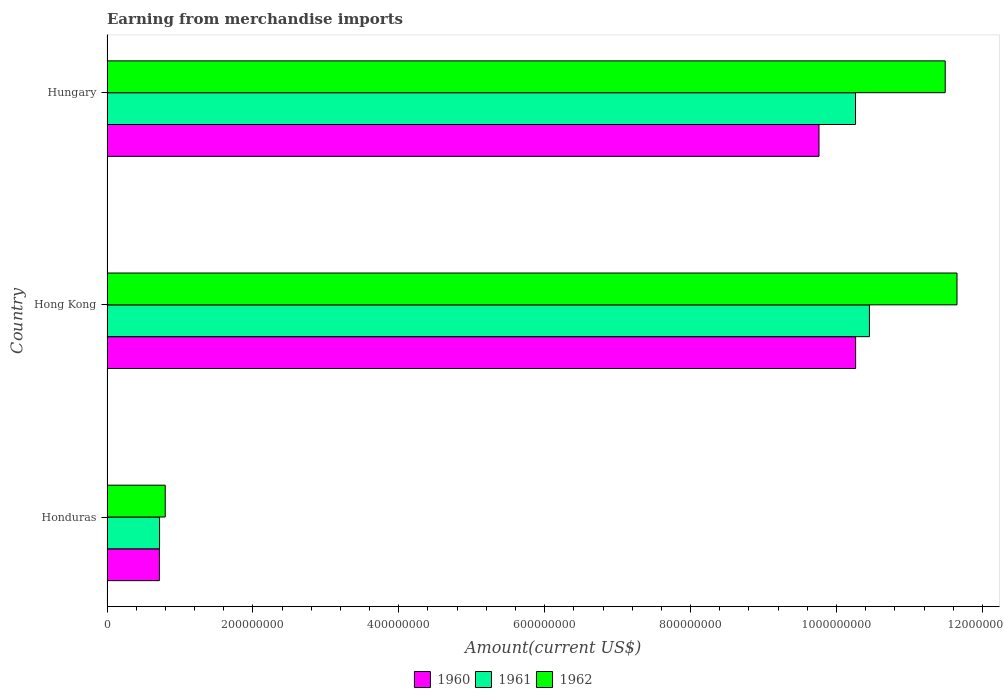How many different coloured bars are there?
Offer a very short reply. 3. Are the number of bars per tick equal to the number of legend labels?
Offer a terse response. Yes. How many bars are there on the 2nd tick from the top?
Your response must be concise. 3. What is the label of the 2nd group of bars from the top?
Give a very brief answer. Hong Kong. In how many cases, is the number of bars for a given country not equal to the number of legend labels?
Offer a terse response. 0. What is the amount earned from merchandise imports in 1961 in Honduras?
Make the answer very short. 7.20e+07. Across all countries, what is the maximum amount earned from merchandise imports in 1962?
Give a very brief answer. 1.17e+09. Across all countries, what is the minimum amount earned from merchandise imports in 1961?
Offer a terse response. 7.20e+07. In which country was the amount earned from merchandise imports in 1961 maximum?
Your response must be concise. Hong Kong. In which country was the amount earned from merchandise imports in 1960 minimum?
Keep it short and to the point. Honduras. What is the total amount earned from merchandise imports in 1962 in the graph?
Make the answer very short. 2.39e+09. What is the difference between the amount earned from merchandise imports in 1962 in Honduras and that in Hungary?
Provide a short and direct response. -1.07e+09. What is the average amount earned from merchandise imports in 1961 per country?
Offer a terse response. 7.14e+08. What is the difference between the amount earned from merchandise imports in 1961 and amount earned from merchandise imports in 1962 in Hungary?
Your response must be concise. -1.23e+08. What is the ratio of the amount earned from merchandise imports in 1960 in Hong Kong to that in Hungary?
Ensure brevity in your answer.  1.05. Is the amount earned from merchandise imports in 1962 in Honduras less than that in Hong Kong?
Offer a very short reply. Yes. What is the difference between the highest and the second highest amount earned from merchandise imports in 1962?
Your answer should be compact. 1.62e+07. What is the difference between the highest and the lowest amount earned from merchandise imports in 1962?
Ensure brevity in your answer.  1.09e+09. In how many countries, is the amount earned from merchandise imports in 1960 greater than the average amount earned from merchandise imports in 1960 taken over all countries?
Make the answer very short. 2. What does the 1st bar from the top in Hungary represents?
Your answer should be very brief. 1962. What does the 1st bar from the bottom in Hong Kong represents?
Offer a very short reply. 1960. Is it the case that in every country, the sum of the amount earned from merchandise imports in 1961 and amount earned from merchandise imports in 1962 is greater than the amount earned from merchandise imports in 1960?
Provide a succinct answer. Yes. How many countries are there in the graph?
Offer a terse response. 3. Where does the legend appear in the graph?
Give a very brief answer. Bottom center. What is the title of the graph?
Keep it short and to the point. Earning from merchandise imports. What is the label or title of the X-axis?
Your answer should be very brief. Amount(current US$). What is the Amount(current US$) of 1960 in Honduras?
Ensure brevity in your answer.  7.18e+07. What is the Amount(current US$) of 1961 in Honduras?
Give a very brief answer. 7.20e+07. What is the Amount(current US$) of 1962 in Honduras?
Ensure brevity in your answer.  7.98e+07. What is the Amount(current US$) in 1960 in Hong Kong?
Give a very brief answer. 1.03e+09. What is the Amount(current US$) of 1961 in Hong Kong?
Provide a short and direct response. 1.05e+09. What is the Amount(current US$) in 1962 in Hong Kong?
Ensure brevity in your answer.  1.17e+09. What is the Amount(current US$) of 1960 in Hungary?
Ensure brevity in your answer.  9.76e+08. What is the Amount(current US$) in 1961 in Hungary?
Provide a short and direct response. 1.03e+09. What is the Amount(current US$) of 1962 in Hungary?
Provide a succinct answer. 1.15e+09. Across all countries, what is the maximum Amount(current US$) in 1960?
Make the answer very short. 1.03e+09. Across all countries, what is the maximum Amount(current US$) in 1961?
Keep it short and to the point. 1.05e+09. Across all countries, what is the maximum Amount(current US$) in 1962?
Provide a succinct answer. 1.17e+09. Across all countries, what is the minimum Amount(current US$) in 1960?
Provide a short and direct response. 7.18e+07. Across all countries, what is the minimum Amount(current US$) of 1961?
Your response must be concise. 7.20e+07. Across all countries, what is the minimum Amount(current US$) of 1962?
Your answer should be compact. 7.98e+07. What is the total Amount(current US$) in 1960 in the graph?
Ensure brevity in your answer.  2.07e+09. What is the total Amount(current US$) in 1961 in the graph?
Provide a short and direct response. 2.14e+09. What is the total Amount(current US$) of 1962 in the graph?
Your response must be concise. 2.39e+09. What is the difference between the Amount(current US$) in 1960 in Honduras and that in Hong Kong?
Your answer should be very brief. -9.54e+08. What is the difference between the Amount(current US$) of 1961 in Honduras and that in Hong Kong?
Ensure brevity in your answer.  -9.73e+08. What is the difference between the Amount(current US$) of 1962 in Honduras and that in Hong Kong?
Ensure brevity in your answer.  -1.09e+09. What is the difference between the Amount(current US$) in 1960 in Honduras and that in Hungary?
Your answer should be compact. -9.04e+08. What is the difference between the Amount(current US$) in 1961 in Honduras and that in Hungary?
Offer a terse response. -9.54e+08. What is the difference between the Amount(current US$) of 1962 in Honduras and that in Hungary?
Provide a succinct answer. -1.07e+09. What is the difference between the Amount(current US$) of 1960 in Hong Kong and that in Hungary?
Your response must be concise. 5.02e+07. What is the difference between the Amount(current US$) of 1961 in Hong Kong and that in Hungary?
Offer a terse response. 1.91e+07. What is the difference between the Amount(current US$) of 1962 in Hong Kong and that in Hungary?
Provide a succinct answer. 1.62e+07. What is the difference between the Amount(current US$) of 1960 in Honduras and the Amount(current US$) of 1961 in Hong Kong?
Provide a succinct answer. -9.73e+08. What is the difference between the Amount(current US$) of 1960 in Honduras and the Amount(current US$) of 1962 in Hong Kong?
Offer a very short reply. -1.09e+09. What is the difference between the Amount(current US$) in 1961 in Honduras and the Amount(current US$) in 1962 in Hong Kong?
Provide a succinct answer. -1.09e+09. What is the difference between the Amount(current US$) of 1960 in Honduras and the Amount(current US$) of 1961 in Hungary?
Offer a very short reply. -9.54e+08. What is the difference between the Amount(current US$) in 1960 in Honduras and the Amount(current US$) in 1962 in Hungary?
Give a very brief answer. -1.08e+09. What is the difference between the Amount(current US$) in 1961 in Honduras and the Amount(current US$) in 1962 in Hungary?
Provide a succinct answer. -1.08e+09. What is the difference between the Amount(current US$) of 1960 in Hong Kong and the Amount(current US$) of 1961 in Hungary?
Your response must be concise. 2.00e+05. What is the difference between the Amount(current US$) of 1960 in Hong Kong and the Amount(current US$) of 1962 in Hungary?
Give a very brief answer. -1.23e+08. What is the difference between the Amount(current US$) of 1961 in Hong Kong and the Amount(current US$) of 1962 in Hungary?
Keep it short and to the point. -1.04e+08. What is the average Amount(current US$) in 1960 per country?
Offer a very short reply. 6.91e+08. What is the average Amount(current US$) in 1961 per country?
Your answer should be very brief. 7.14e+08. What is the average Amount(current US$) in 1962 per country?
Your answer should be very brief. 7.98e+08. What is the difference between the Amount(current US$) in 1960 and Amount(current US$) in 1962 in Honduras?
Offer a terse response. -8.00e+06. What is the difference between the Amount(current US$) in 1961 and Amount(current US$) in 1962 in Honduras?
Ensure brevity in your answer.  -7.75e+06. What is the difference between the Amount(current US$) in 1960 and Amount(current US$) in 1961 in Hong Kong?
Provide a short and direct response. -1.89e+07. What is the difference between the Amount(current US$) of 1960 and Amount(current US$) of 1962 in Hong Kong?
Provide a short and direct response. -1.39e+08. What is the difference between the Amount(current US$) of 1961 and Amount(current US$) of 1962 in Hong Kong?
Offer a very short reply. -1.20e+08. What is the difference between the Amount(current US$) of 1960 and Amount(current US$) of 1961 in Hungary?
Your answer should be compact. -5.00e+07. What is the difference between the Amount(current US$) in 1960 and Amount(current US$) in 1962 in Hungary?
Offer a very short reply. -1.73e+08. What is the difference between the Amount(current US$) in 1961 and Amount(current US$) in 1962 in Hungary?
Keep it short and to the point. -1.23e+08. What is the ratio of the Amount(current US$) in 1960 in Honduras to that in Hong Kong?
Your response must be concise. 0.07. What is the ratio of the Amount(current US$) in 1961 in Honduras to that in Hong Kong?
Your response must be concise. 0.07. What is the ratio of the Amount(current US$) of 1962 in Honduras to that in Hong Kong?
Offer a terse response. 0.07. What is the ratio of the Amount(current US$) in 1960 in Honduras to that in Hungary?
Provide a short and direct response. 0.07. What is the ratio of the Amount(current US$) of 1961 in Honduras to that in Hungary?
Offer a very short reply. 0.07. What is the ratio of the Amount(current US$) of 1962 in Honduras to that in Hungary?
Keep it short and to the point. 0.07. What is the ratio of the Amount(current US$) in 1960 in Hong Kong to that in Hungary?
Give a very brief answer. 1.05. What is the ratio of the Amount(current US$) in 1961 in Hong Kong to that in Hungary?
Your response must be concise. 1.02. What is the ratio of the Amount(current US$) of 1962 in Hong Kong to that in Hungary?
Keep it short and to the point. 1.01. What is the difference between the highest and the second highest Amount(current US$) in 1960?
Give a very brief answer. 5.02e+07. What is the difference between the highest and the second highest Amount(current US$) of 1961?
Make the answer very short. 1.91e+07. What is the difference between the highest and the second highest Amount(current US$) in 1962?
Provide a short and direct response. 1.62e+07. What is the difference between the highest and the lowest Amount(current US$) in 1960?
Offer a very short reply. 9.54e+08. What is the difference between the highest and the lowest Amount(current US$) in 1961?
Your answer should be very brief. 9.73e+08. What is the difference between the highest and the lowest Amount(current US$) of 1962?
Ensure brevity in your answer.  1.09e+09. 